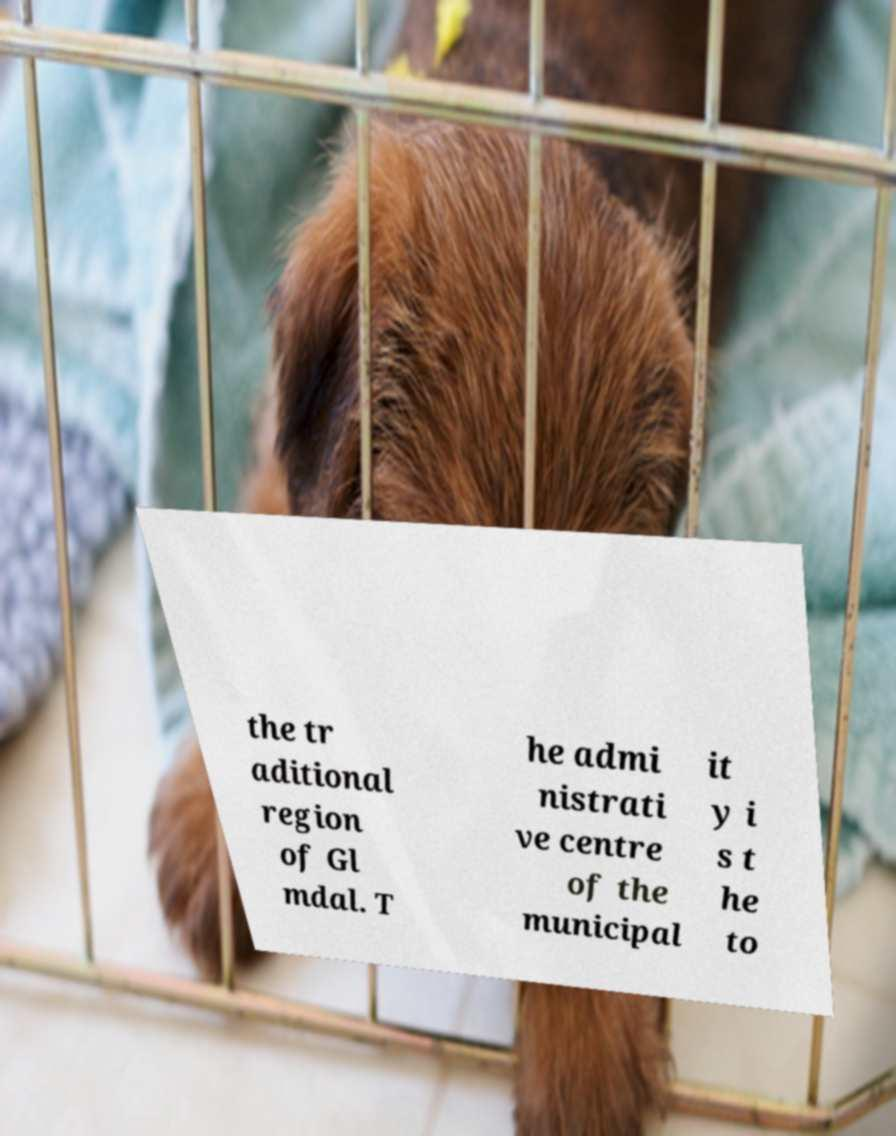I need the written content from this picture converted into text. Can you do that? the tr aditional region of Gl mdal. T he admi nistrati ve centre of the municipal it y i s t he to 